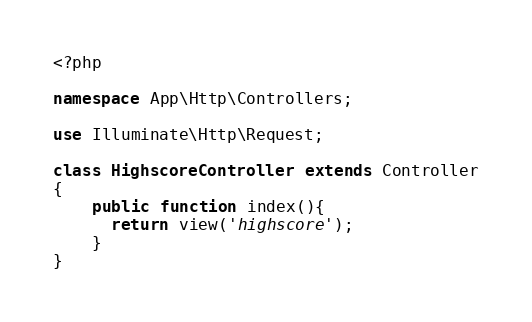<code> <loc_0><loc_0><loc_500><loc_500><_PHP_><?php

namespace App\Http\Controllers;

use Illuminate\Http\Request;

class HighscoreController extends Controller
{
    public function index(){
      return view('highscore');
    }
}
</code> 